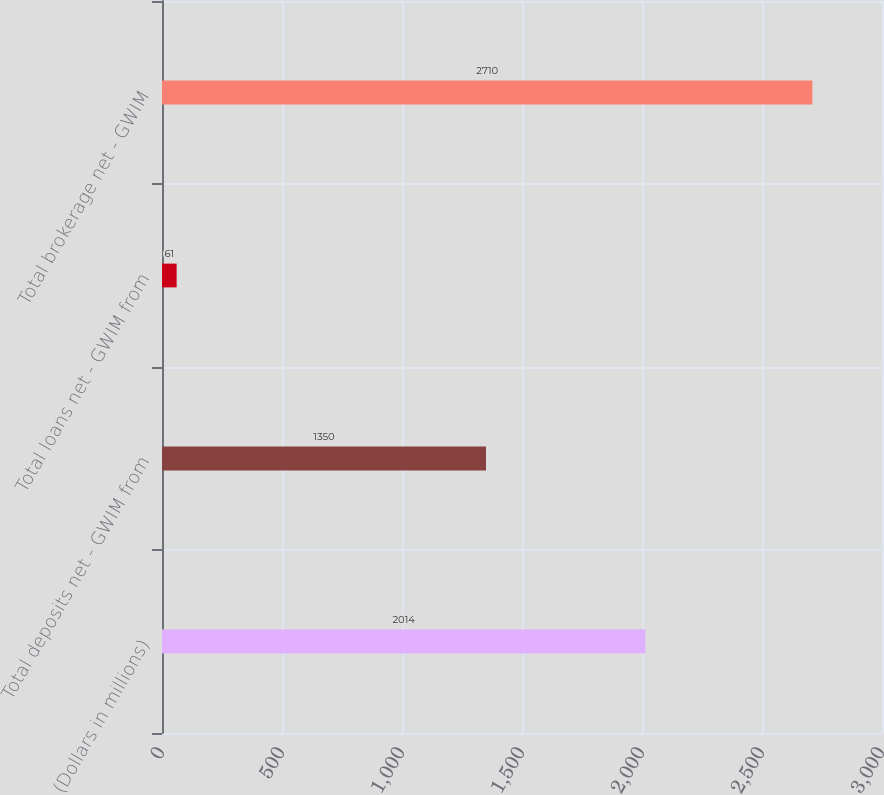Convert chart to OTSL. <chart><loc_0><loc_0><loc_500><loc_500><bar_chart><fcel>(Dollars in millions)<fcel>Total deposits net - GWIM from<fcel>Total loans net - GWIM from<fcel>Total brokerage net - GWIM<nl><fcel>2014<fcel>1350<fcel>61<fcel>2710<nl></chart> 